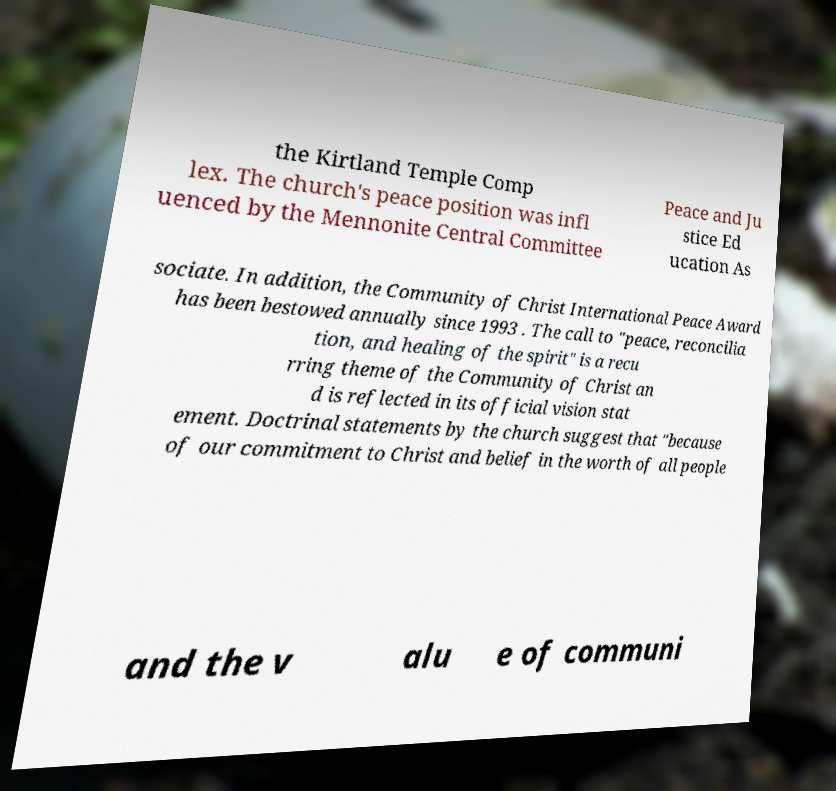For documentation purposes, I need the text within this image transcribed. Could you provide that? the Kirtland Temple Comp lex. The church's peace position was infl uenced by the Mennonite Central Committee Peace and Ju stice Ed ucation As sociate. In addition, the Community of Christ International Peace Award has been bestowed annually since 1993 . The call to "peace, reconcilia tion, and healing of the spirit" is a recu rring theme of the Community of Christ an d is reflected in its official vision stat ement. Doctrinal statements by the church suggest that "because of our commitment to Christ and belief in the worth of all people and the v alu e of communi 